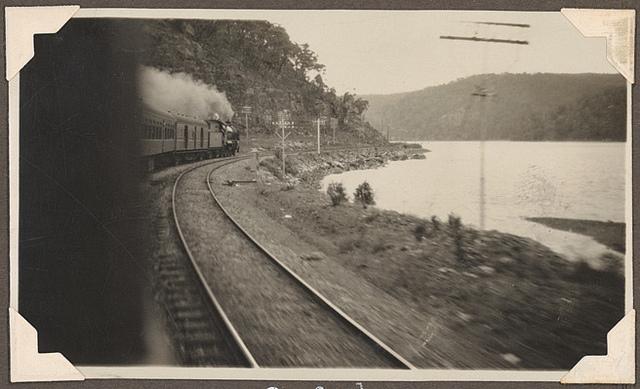Is the train crossing a long bridge?
Short answer required. No. What color is the photo?
Short answer required. Black and white. How many trains could pass here at the same time?
Short answer required. 2. What type of transportation can be found here?
Keep it brief. Train. What is this train commemorating?
Be succinct. Travel. Are there any cars or trains in this photo?
Keep it brief. Yes. 